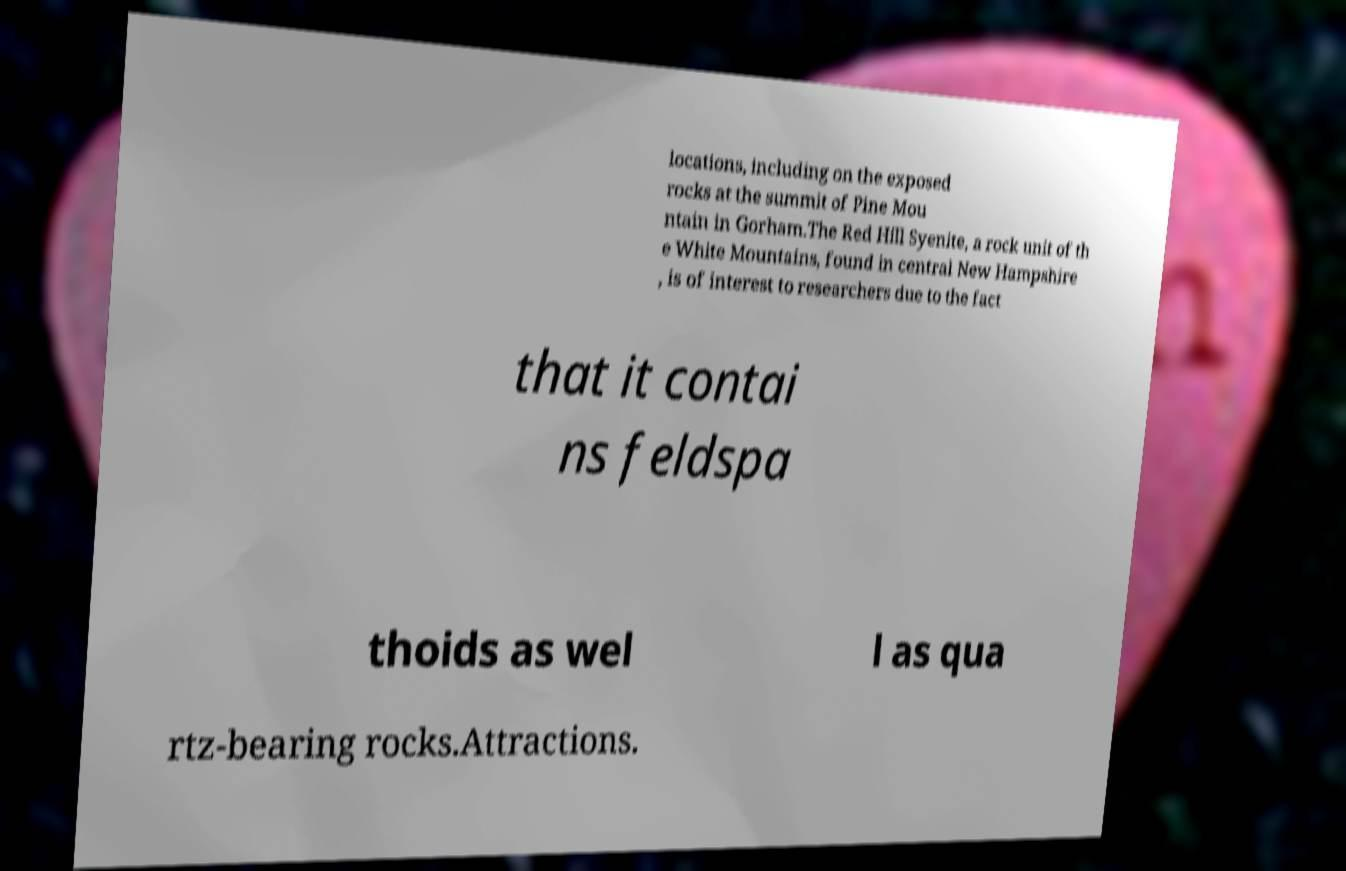Please identify and transcribe the text found in this image. locations, including on the exposed rocks at the summit of Pine Mou ntain in Gorham.The Red Hill Syenite, a rock unit of th e White Mountains, found in central New Hampshire , is of interest to researchers due to the fact that it contai ns feldspa thoids as wel l as qua rtz-bearing rocks.Attractions. 